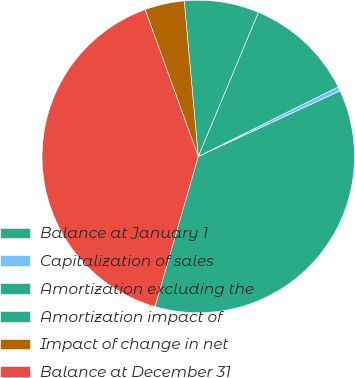Convert chart. <chart><loc_0><loc_0><loc_500><loc_500><pie_chart><fcel>Balance at January 1<fcel>Capitalization of sales<fcel>Amortization excluding the<fcel>Amortization impact of<fcel>Impact of change in net<fcel>Balance at December 31<nl><fcel>36.37%<fcel>0.45%<fcel>11.36%<fcel>7.72%<fcel>4.09%<fcel>40.01%<nl></chart> 